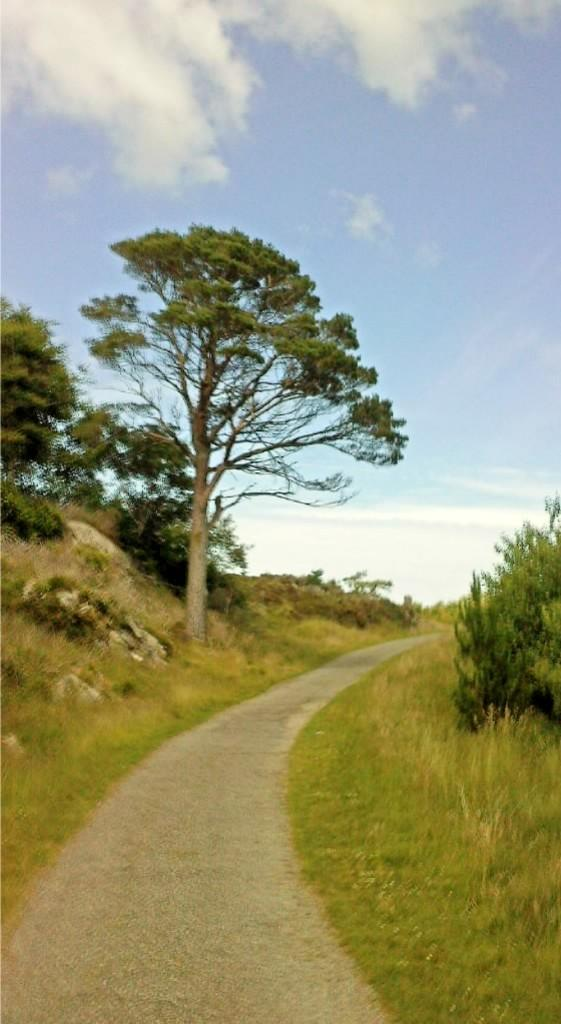What is the main feature of the image? There is a road in the image. What can be seen on the left side of the image? There are trees on the left side of the image. What can be seen on the right side of the image? There are trees on the right side of the image. What type of vegetation is present in the image? There are plants in the image. What is the color of the grass in the image? There is green grass on the ground. What is visible in the sky in the image? There are clouds in the sky. How does the road express anger in the image? The road does not express anger in the image; it is an inanimate object and cannot have emotions. 